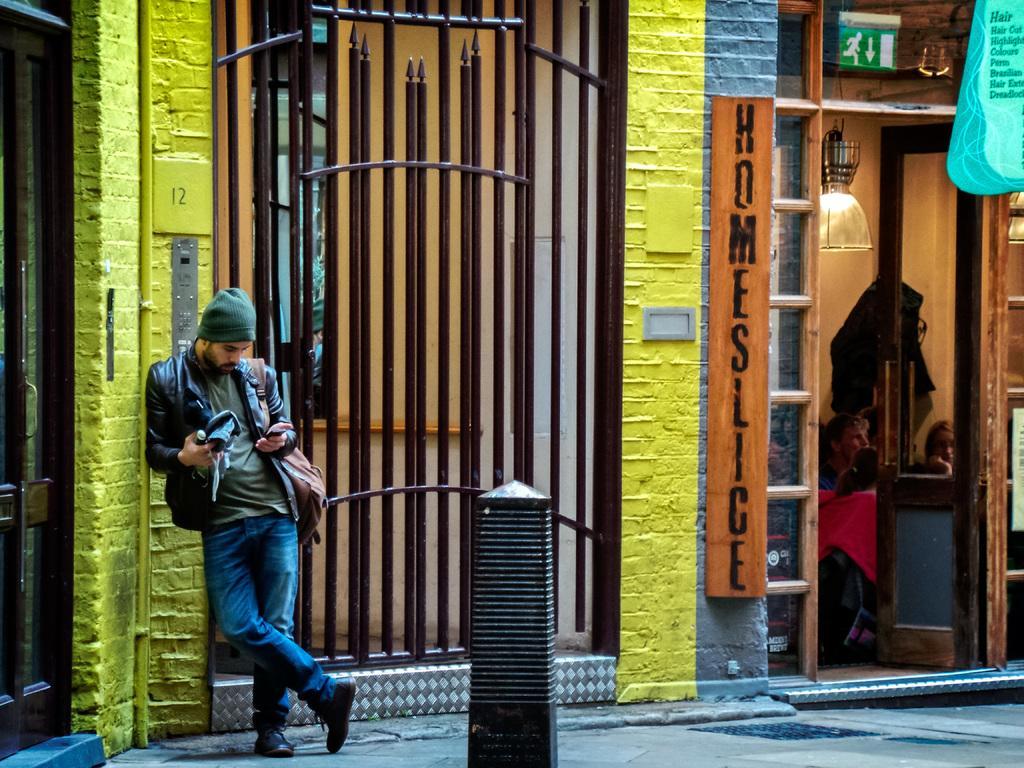In one or two sentences, can you explain what this image depicts? In the middle of the picture, we see a pole in black color. Beside that, we see a man in the black jacket is standing. He is wearing a cap and a bag. He is holding a mobile phone in his hand. Behind him, we see a yellow wall. Beside that, we see a gate in brown color. Beside that, we see a building in brown and grey color. We see a board in brown color with some text written on it. Beside that, we see the glass door from which we can see the people. Behind them, we see the wall and a light. In the right top, we see a board in blue color with some text written on it. On the left side, we see the glass door. At the bottom, we see the pavement. 